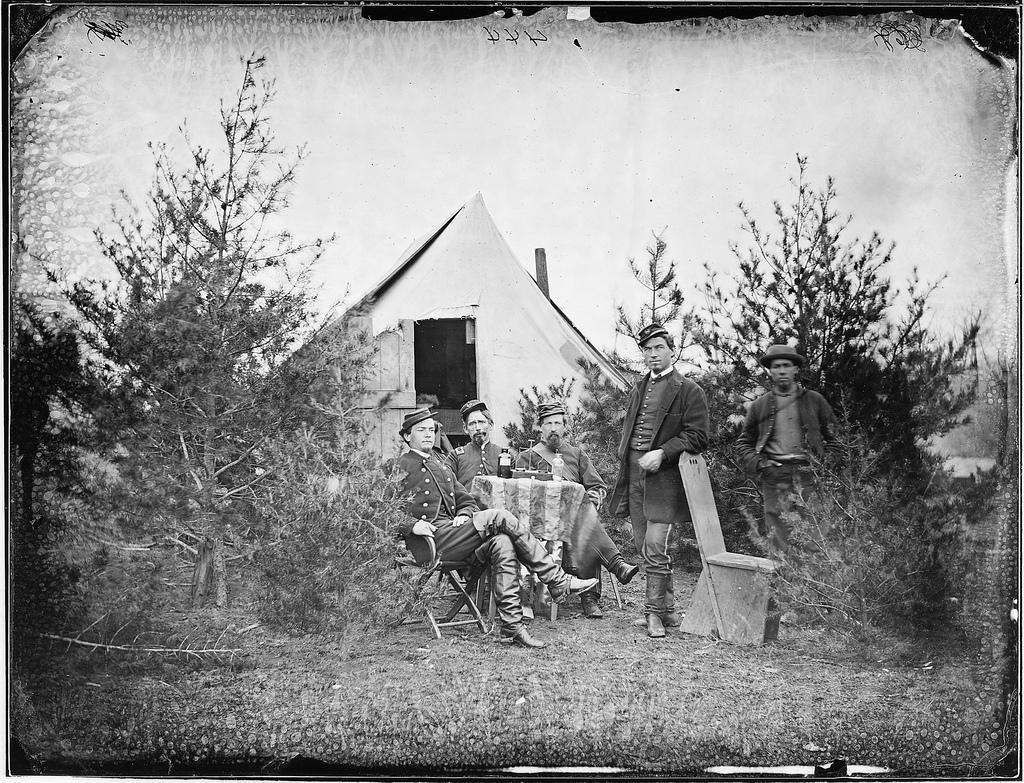How many people are in the image? There is a group of people in the image, but the exact number is not specified. What are the people in the image doing? Some people are sitting, while others are standing. What can be seen in the background of the image? There is a hut and trees visible in the background of the image. What type of silk is being used to create the foot of the hut in the image? There is no mention of silk or any specific material used for the hut in the image. The hut's construction is not described in detail. 